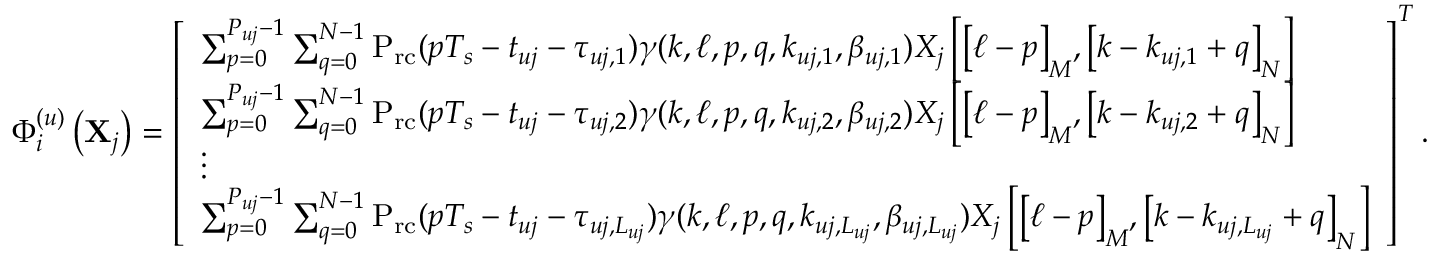Convert formula to latex. <formula><loc_0><loc_0><loc_500><loc_500>\begin{array} { r } { \Phi _ { i } ^ { ( u ) } \left ( { { { X } _ { j } } } \right ) = \left [ \begin{array} { l } { { \sum _ { p = 0 } ^ { { P _ { u j } } - 1 } { \sum _ { q = 0 } ^ { N - 1 } { { { P } _ { r c } } ( p { T _ { s } } - { t _ { u j } } - { \tau _ { u j , 1 } } ) \gamma ( k , \ell , p , q , { k _ { u j , 1 } } , { \beta _ { u j , 1 } } ) { X _ { j } } \left [ { { { \left [ { \ell - p } \right ] } _ { M } } , { { \left [ { k - { k _ { u j , 1 } } + q } \right ] } _ { N } } } \right ] } } } } \\ { { \sum _ { p = 0 } ^ { { P _ { u j } } - 1 } { \sum _ { q = 0 } ^ { N - 1 } { { { P } _ { r c } } ( p { T _ { s } } - { t _ { u j } } - { \tau _ { u j , 2 } } ) \gamma ( k , \ell , p , q , { k _ { u j , 2 } } , { \beta _ { u j , 2 } } ) { X _ { j } } \left [ { { { \left [ { \ell - p } \right ] } _ { M } } , { { \left [ { k - { k _ { u j , 2 } } + q } \right ] } _ { N } } } \right ] } } } } \\ { \vdots } \\ { { \sum _ { p = 0 } ^ { { P _ { u j } } - 1 } { \sum _ { q = 0 } ^ { N - 1 } { { { P } _ { r c } } ( p { T _ { s } } - { t _ { u j } } - { \tau _ { u j , { L _ { u j } } } } ) \gamma ( k , \ell , p , q , { k _ { u j , { L _ { u j } } } } , { \beta _ { u j , { L _ { u j } } } } ) { X _ { j } } \left [ { { { \left [ { \ell - p } \right ] } _ { M } } , { { \left [ { k - { k _ { u j , { L _ { u j } } } } + q } \right ] } _ { N } } } \right ] } } } } \end{array} \right ] ^ { T } . } \end{array}</formula> 